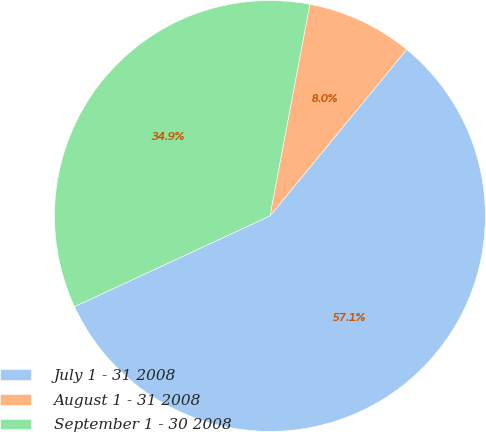Convert chart. <chart><loc_0><loc_0><loc_500><loc_500><pie_chart><fcel>July 1 - 31 2008<fcel>August 1 - 31 2008<fcel>September 1 - 30 2008<nl><fcel>57.14%<fcel>7.98%<fcel>34.88%<nl></chart> 